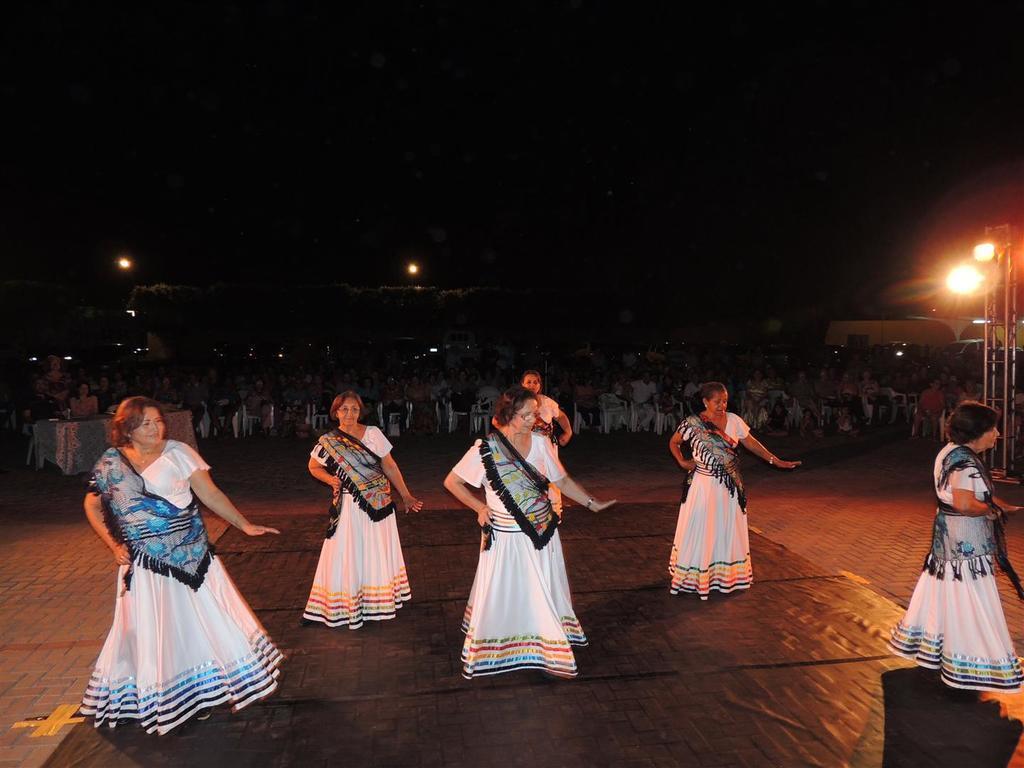Please provide a concise description of this image. Here we can see few persons are dancing on the floor. Here we can see crowd, table, poles, and lights. There is a dark background. 